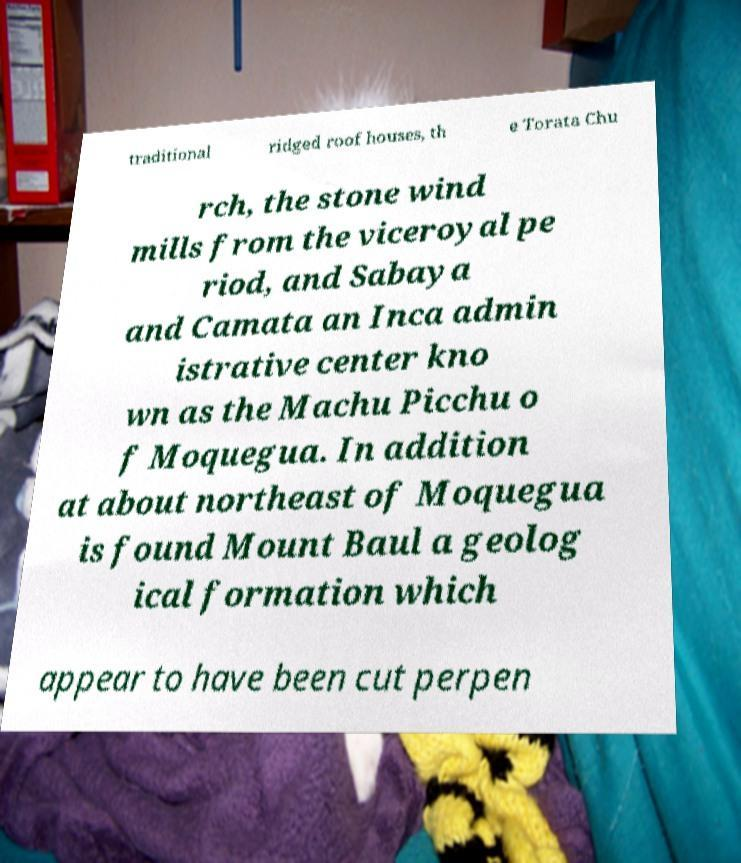What messages or text are displayed in this image? I need them in a readable, typed format. traditional ridged roof houses, th e Torata Chu rch, the stone wind mills from the viceroyal pe riod, and Sabaya and Camata an Inca admin istrative center kno wn as the Machu Picchu o f Moquegua. In addition at about northeast of Moquegua is found Mount Baul a geolog ical formation which appear to have been cut perpen 